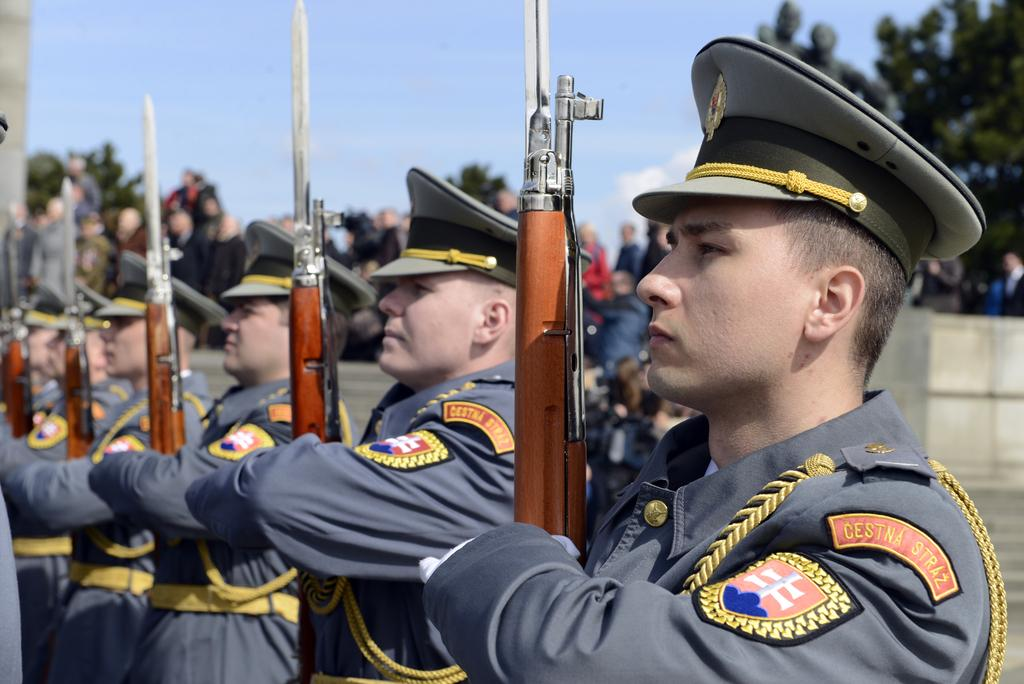What can be seen in the foreground of the picture? There are soldiers in the foreground of the picture. What are the soldiers holding in the image? The soldiers are holding guns. What can be observed about the background of the image? The background of the image is blurred. What else is visible in the background of the image? There are people and a tree in the background of the image. How would you describe the weather in the image? The sky is cloudy in the image. What type of clock is hanging from the tree in the image? There is no clock present in the image, and the tree does not have anything hanging from it. 